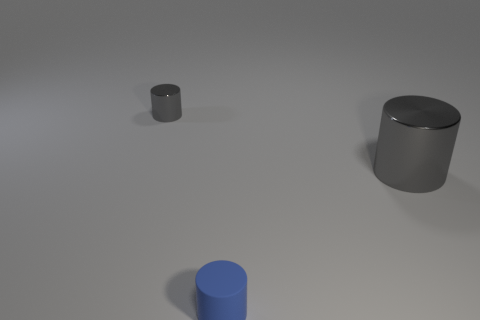What is the shape of the object that is in front of the small shiny object and to the left of the big cylinder?
Make the answer very short. Cylinder. How many other objects are the same color as the small metallic object?
Keep it short and to the point. 1. Does the cylinder to the right of the blue matte object have the same color as the small metallic object?
Your answer should be compact. Yes. How many other things are there of the same shape as the tiny blue thing?
Make the answer very short. 2. Are any small red metal cylinders visible?
Provide a succinct answer. No. How many other objects are the same size as the blue cylinder?
Keep it short and to the point. 1. There is a metallic object that is right of the tiny gray object; is its color the same as the small thing that is behind the large metal object?
Your answer should be very brief. Yes. There is a rubber object that is the same shape as the large shiny object; what is its size?
Make the answer very short. Small. Is the material of the small object that is left of the small rubber cylinder the same as the cylinder that is in front of the big gray metallic cylinder?
Offer a very short reply. No. What number of metallic things are big yellow objects or tiny cylinders?
Provide a short and direct response. 1. 